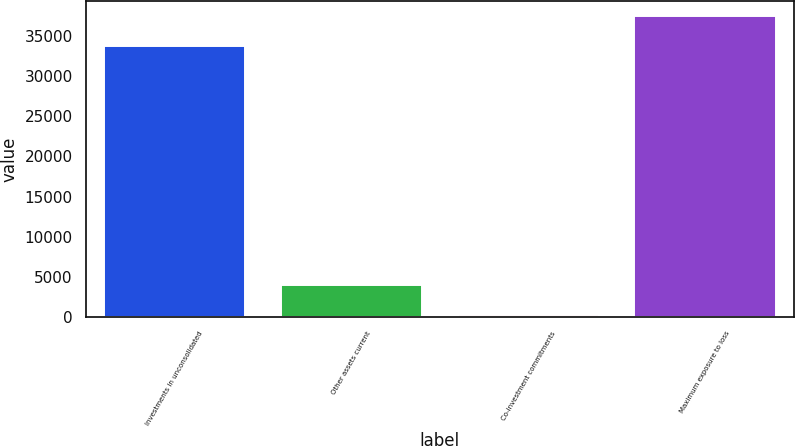<chart> <loc_0><loc_0><loc_500><loc_500><bar_chart><fcel>Investments in unconsolidated<fcel>Other assets current<fcel>Co-investment commitments<fcel>Maximum exposure to loss<nl><fcel>33787<fcel>3933.4<fcel>200<fcel>37534<nl></chart> 